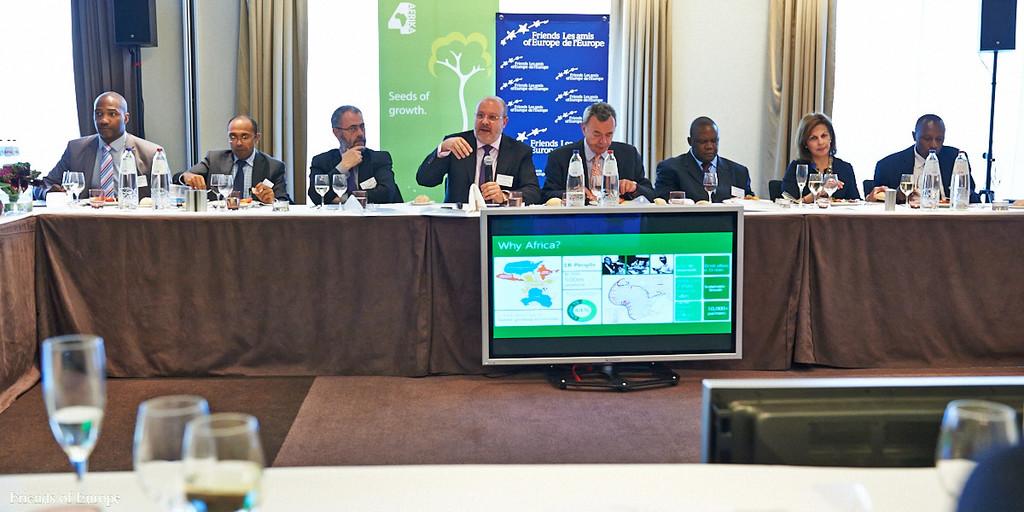What country is the meeting about?
Provide a succinct answer. Africa. What country is the focus on the monitor page?
Your answer should be compact. Africa. 